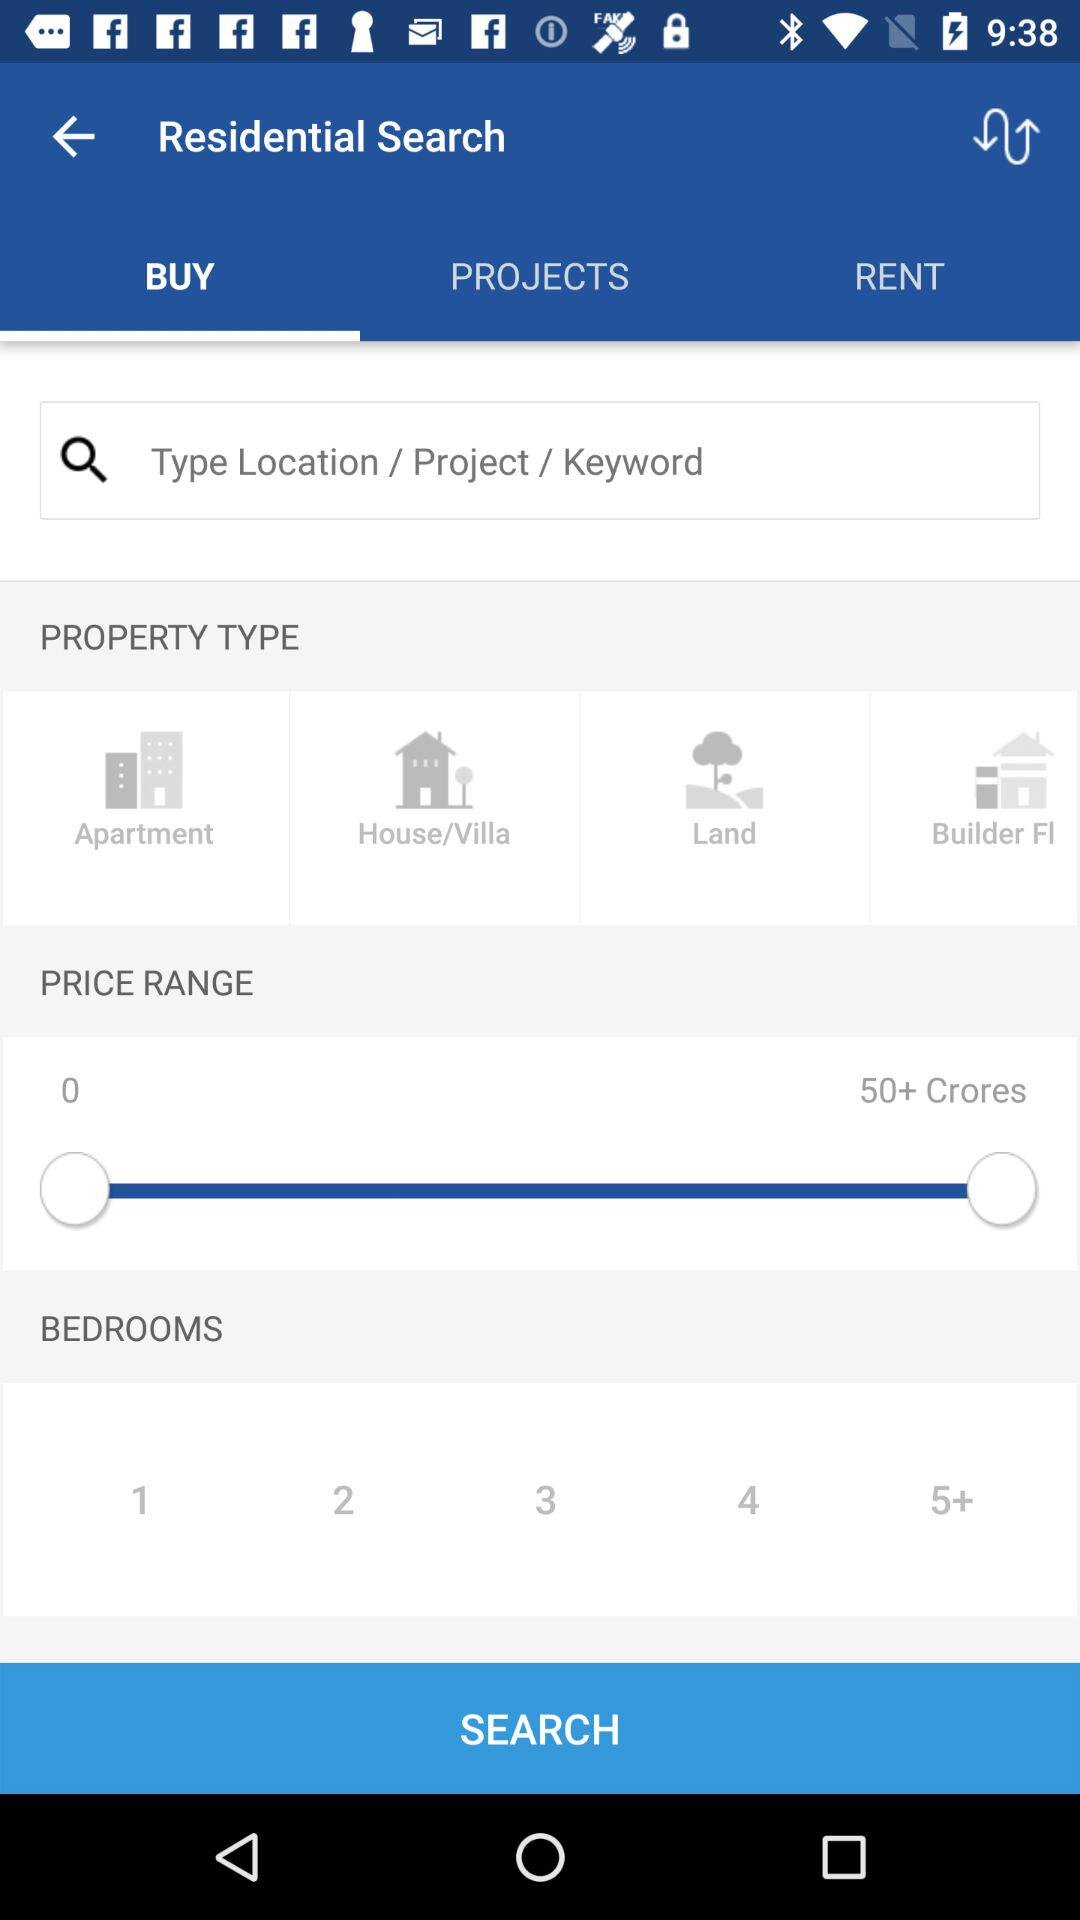How many bedrooms are available in the search results?
Answer the question using a single word or phrase. 1, 2, 3, 4, 5+ 